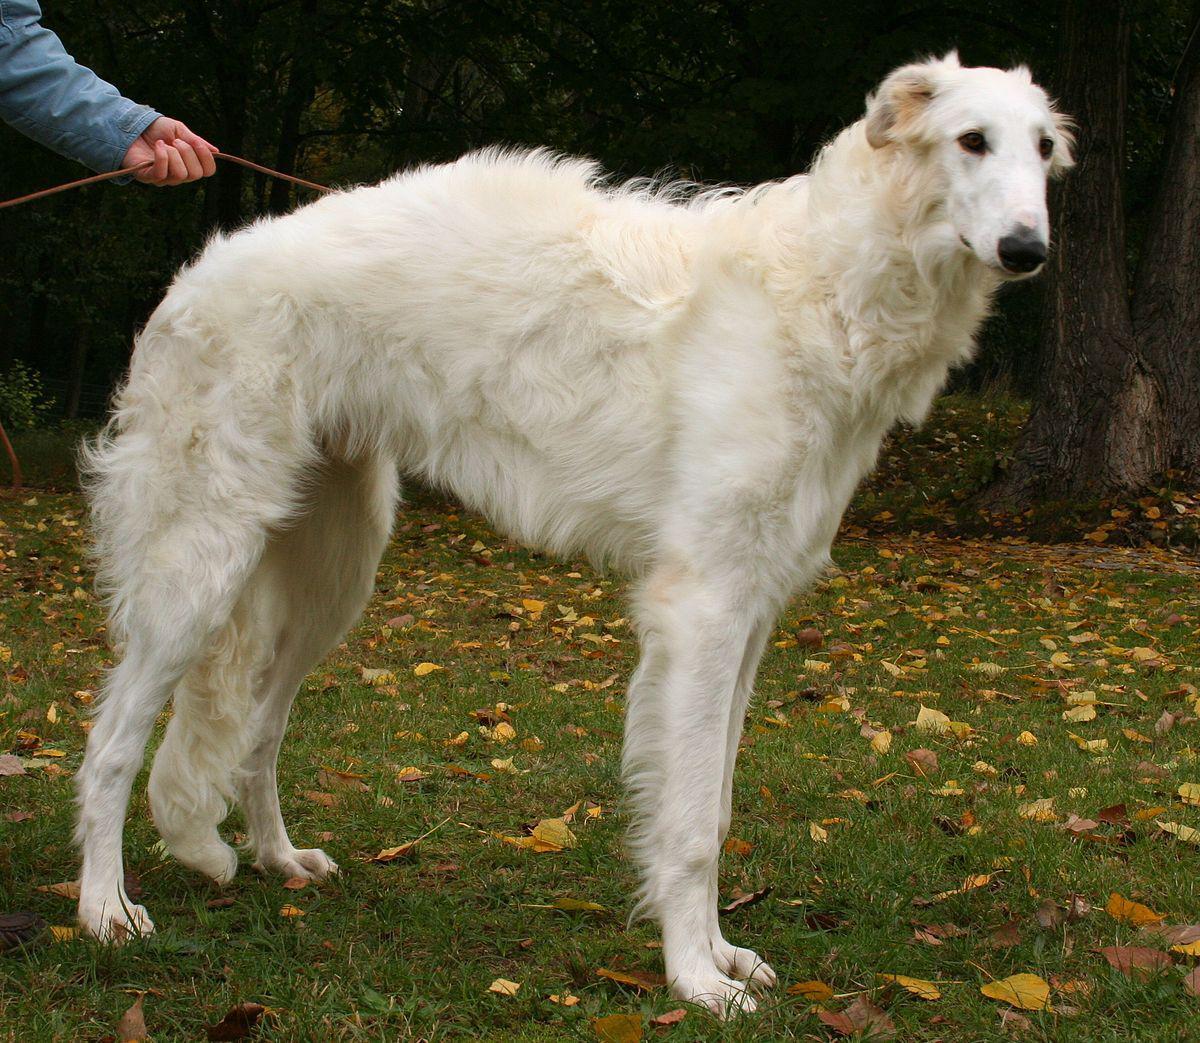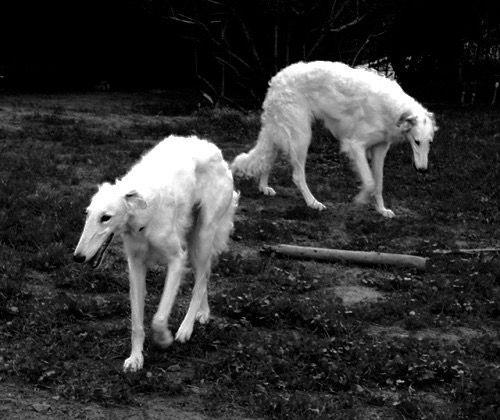The first image is the image on the left, the second image is the image on the right. Evaluate the accuracy of this statement regarding the images: "The single white dog in the image on the left is standing in a grassy area.". Is it true? Answer yes or no. Yes. The first image is the image on the left, the second image is the image on the right. Considering the images on both sides, is "The left image contains at least three times as many hounds as the right image." valid? Answer yes or no. No. 